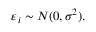<formula> <loc_0><loc_0><loc_500><loc_500>\varepsilon _ { i } \sim N ( 0 , \sigma ^ { 2 } ) .</formula> 